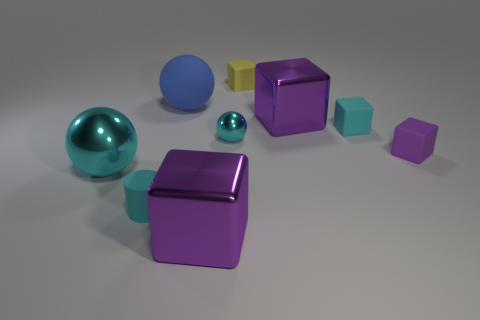What material is the tiny sphere that is the same color as the matte cylinder?
Provide a succinct answer. Metal. What number of gray objects are tiny spheres or blocks?
Ensure brevity in your answer.  0. What is the size of the other metal sphere that is the same color as the small sphere?
Ensure brevity in your answer.  Large. Are there more large green balls than small rubber cylinders?
Ensure brevity in your answer.  No. Does the large shiny ball have the same color as the tiny ball?
Your answer should be very brief. Yes. What number of things are either blue objects or big purple things in front of the small cyan shiny ball?
Keep it short and to the point. 2. How many other objects are there of the same shape as the purple rubber object?
Your response must be concise. 4. Is the number of big spheres that are right of the big blue rubber ball less than the number of blue balls on the left side of the yellow rubber thing?
Provide a short and direct response. Yes. There is a small yellow object that is the same material as the small purple cube; what is its shape?
Keep it short and to the point. Cube. Are there any other things that are the same color as the rubber sphere?
Your answer should be compact. No. 